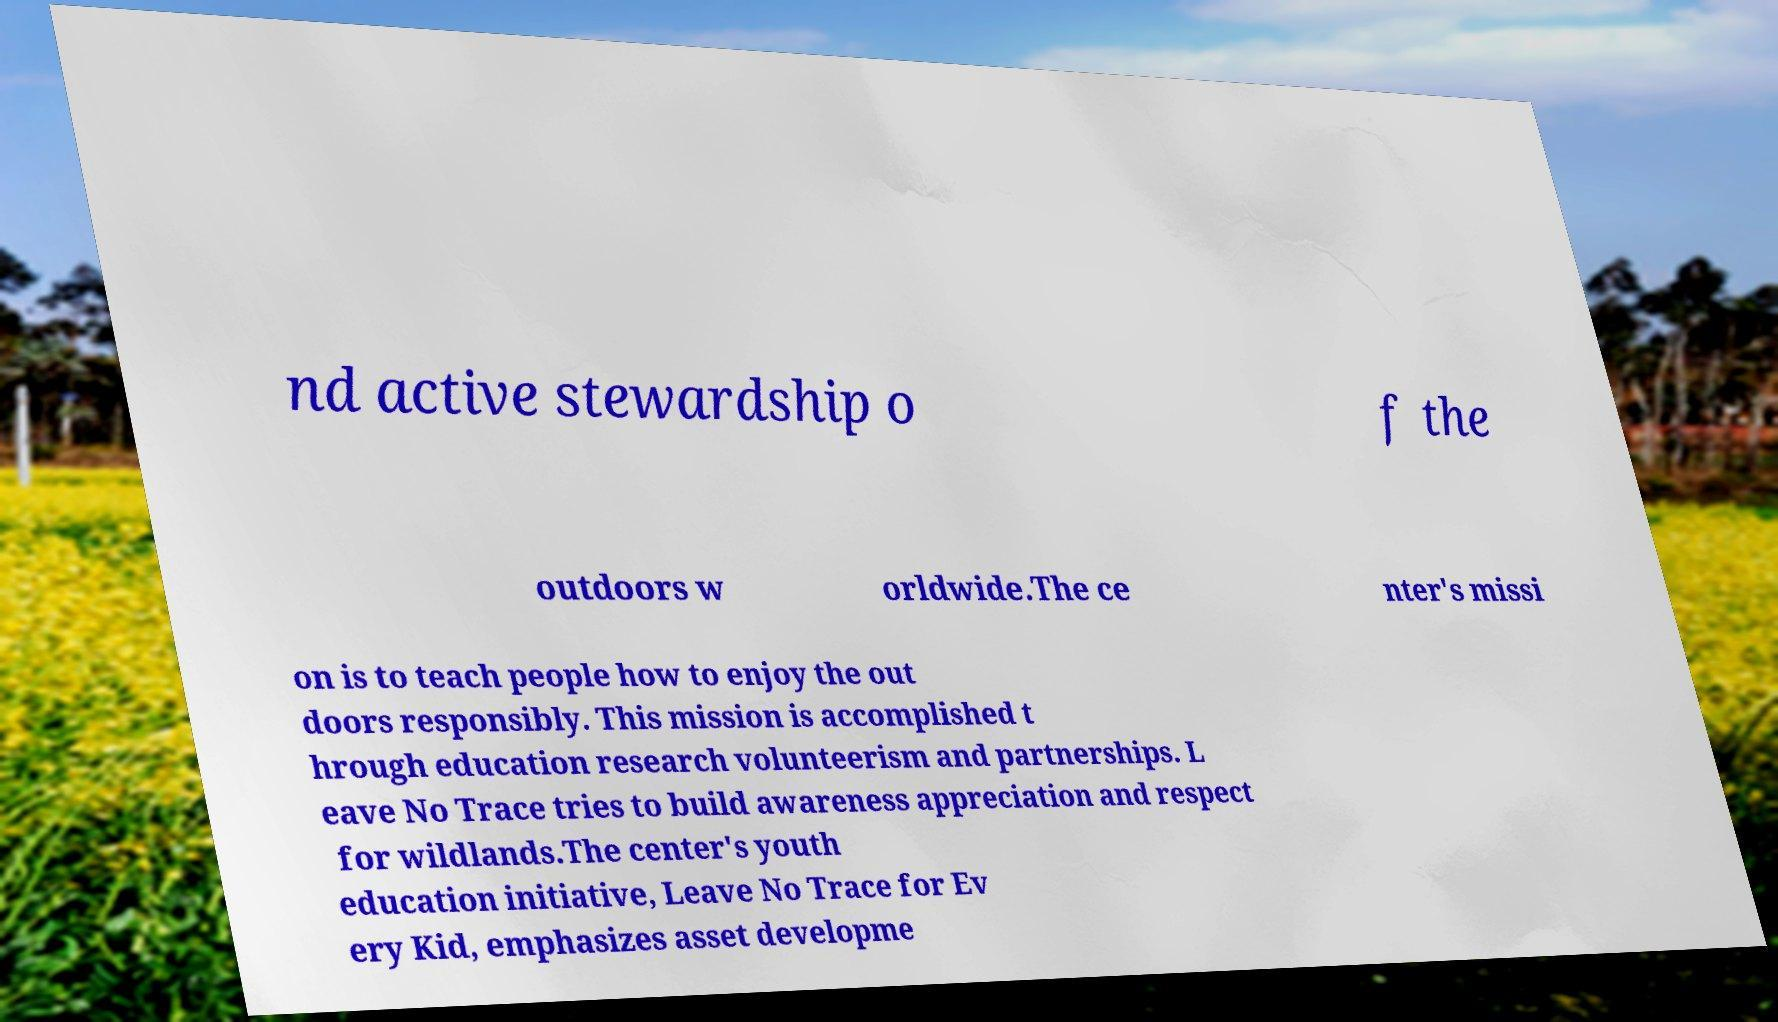There's text embedded in this image that I need extracted. Can you transcribe it verbatim? nd active stewardship o f the outdoors w orldwide.The ce nter's missi on is to teach people how to enjoy the out doors responsibly. This mission is accomplished t hrough education research volunteerism and partnerships. L eave No Trace tries to build awareness appreciation and respect for wildlands.The center's youth education initiative, Leave No Trace for Ev ery Kid, emphasizes asset developme 